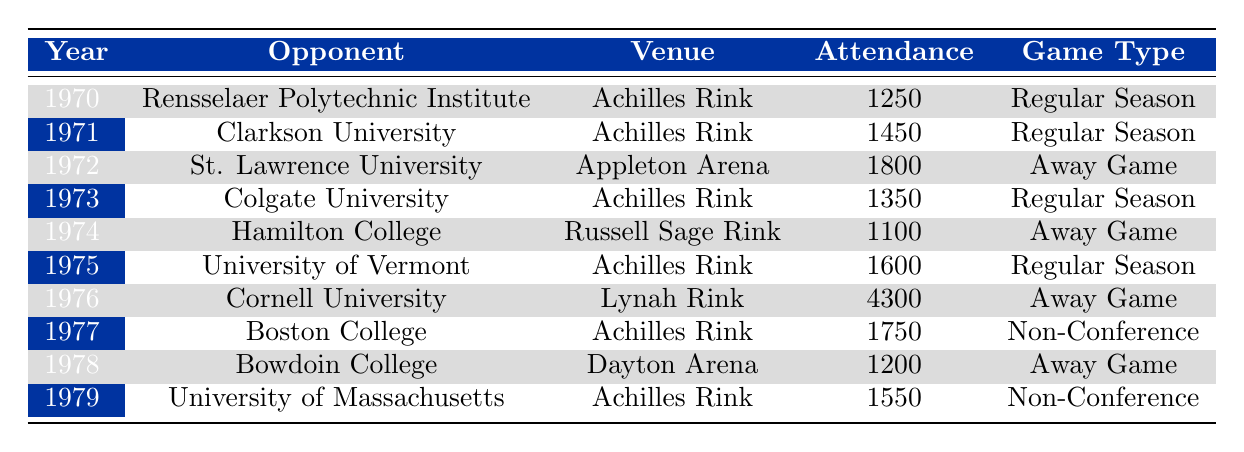What was the highest attendance recorded for a game involving the Union Skating Dutchmen? The highest attendance recorded in the table is 4300 for the away game against Cornell University in 1976.
Answer: 4300 How many games did the Union Skating Dutchmen play in 1977? The table shows that the Union Skating Dutchmen played 1 game in 1977, which was against Boston College.
Answer: 1 What is the average attendance for home games played at Achilles Rink? The games at Achilles Rink are in 1970 (1250), 1971 (1450), 1973 (1350), 1975 (1600), 1977 (1750), and 1979 (1550). Summing these gives 1250 + 1450 + 1350 + 1600 + 1750 + 1550 = 10000. There are 6 home games, so the average attendance is 10000/6 = 1666.67.
Answer: 1666.67 Did the Union Skating Dutchmen have more non-conference games than away games? The table indicates that they had 2 non-conference games (in 1977 and 1979) and 3 away games (in 1972, 1974, and 1976), thus they had fewer non-conference games.
Answer: No What was the total attendance for all games played by the Union Skating Dutchmen in the 1970s? To obtain the total attendance, we add the attendance figures for all 10 games: 1250, 1450, 1800, 1350, 1100, 1600, 4300, 1750, 1200, and 1550. Adding these numbers gives a total attendance of 16,800.
Answer: 16800 Which opponent had the lowest attendance recorded and what was it? Checking the data, the lowest attendance is 1100, which occurred during the away game against Hamilton College in 1974.
Answer: 1100 How many different venues were used for games in the 1970s? The venues listed in the data are Achilles Rink, Appleton Arena, Russell Sage Rink, Lynah Rink, and Dayton Arena. There are 5 distinct venues used during that period.
Answer: 5 What year saw the second highest attendance, and how much was it? Looking at the attendance figures, the second highest is 1750 in the year 1977 against Boston College.
Answer: 1977, 1750 